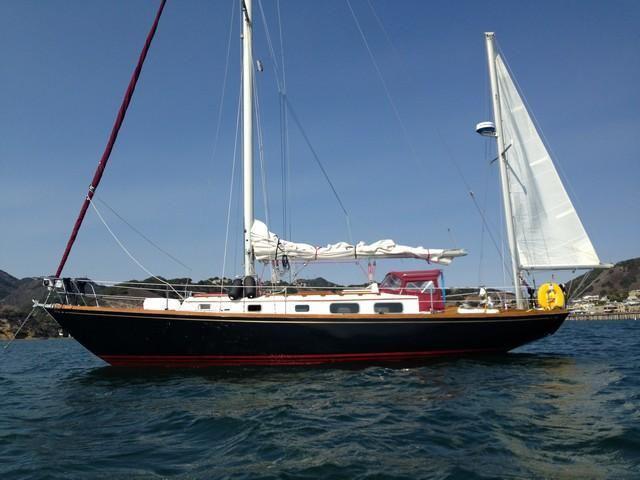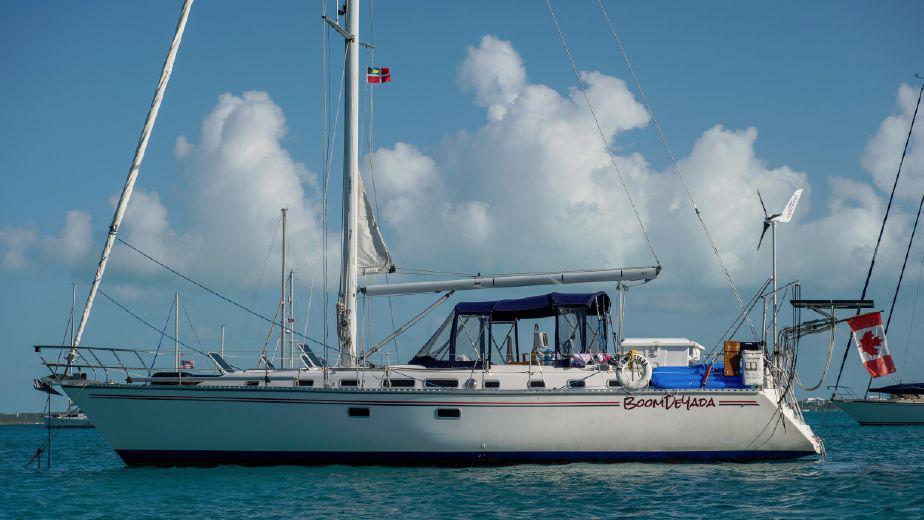The first image is the image on the left, the second image is the image on the right. For the images displayed, is the sentence "the boats in the image pair have no sails raised" factually correct? Answer yes or no. No. The first image is the image on the left, the second image is the image on the right. For the images displayed, is the sentence "There is a ship with at least one sail unfurled." factually correct? Answer yes or no. Yes. 